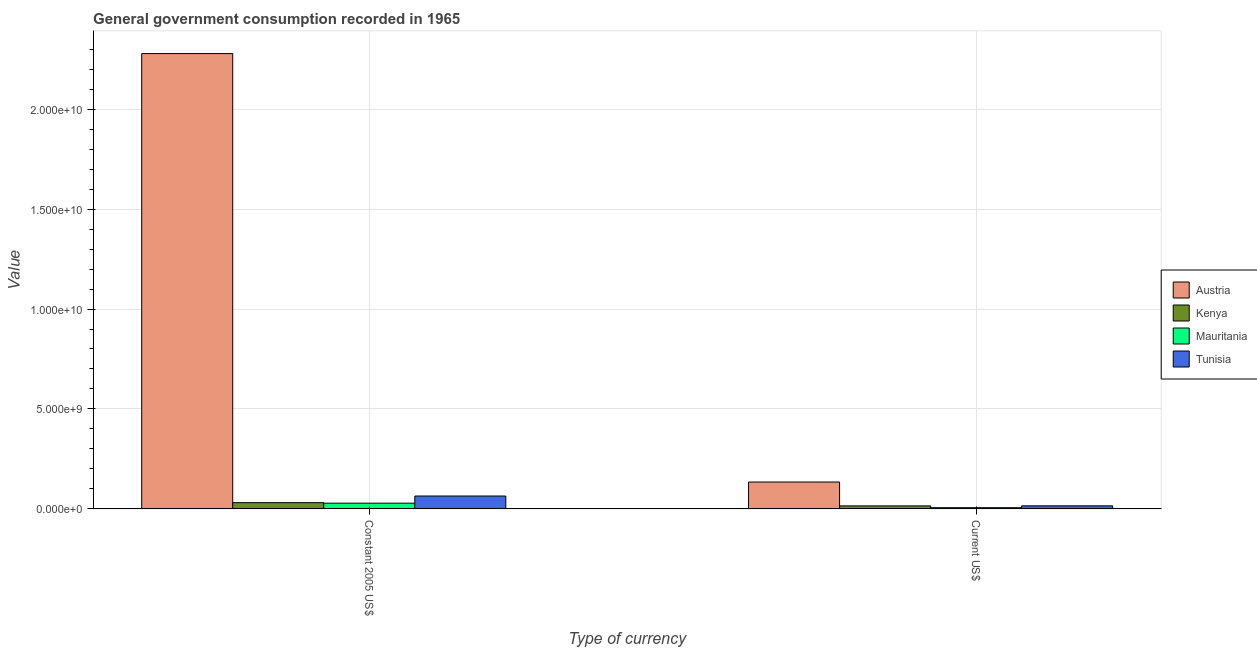How many different coloured bars are there?
Your answer should be compact. 4. Are the number of bars per tick equal to the number of legend labels?
Make the answer very short. Yes. How many bars are there on the 2nd tick from the left?
Your response must be concise. 4. How many bars are there on the 1st tick from the right?
Offer a terse response. 4. What is the label of the 2nd group of bars from the left?
Your answer should be compact. Current US$. What is the value consumed in constant 2005 us$ in Tunisia?
Offer a terse response. 6.42e+08. Across all countries, what is the maximum value consumed in current us$?
Ensure brevity in your answer.  1.34e+09. Across all countries, what is the minimum value consumed in current us$?
Provide a short and direct response. 5.77e+07. In which country was the value consumed in current us$ minimum?
Provide a succinct answer. Mauritania. What is the total value consumed in current us$ in the graph?
Ensure brevity in your answer.  1.70e+09. What is the difference between the value consumed in constant 2005 us$ in Mauritania and that in Tunisia?
Make the answer very short. -3.58e+08. What is the difference between the value consumed in current us$ in Mauritania and the value consumed in constant 2005 us$ in Austria?
Keep it short and to the point. -2.27e+1. What is the average value consumed in constant 2005 us$ per country?
Give a very brief answer. 6.00e+09. What is the difference between the value consumed in constant 2005 us$ and value consumed in current us$ in Tunisia?
Provide a short and direct response. 4.91e+08. In how many countries, is the value consumed in constant 2005 us$ greater than 6000000000 ?
Keep it short and to the point. 1. What is the ratio of the value consumed in constant 2005 us$ in Mauritania to that in Kenya?
Make the answer very short. 0.92. What does the 4th bar from the left in Constant 2005 US$ represents?
Keep it short and to the point. Tunisia. What does the 2nd bar from the right in Current US$ represents?
Your answer should be very brief. Mauritania. How many bars are there?
Your answer should be very brief. 8. Are all the bars in the graph horizontal?
Keep it short and to the point. No. How many countries are there in the graph?
Your answer should be very brief. 4. Does the graph contain grids?
Give a very brief answer. Yes. How are the legend labels stacked?
Give a very brief answer. Vertical. What is the title of the graph?
Keep it short and to the point. General government consumption recorded in 1965. What is the label or title of the X-axis?
Make the answer very short. Type of currency. What is the label or title of the Y-axis?
Offer a terse response. Value. What is the Value of Austria in Constant 2005 US$?
Your response must be concise. 2.28e+1. What is the Value in Kenya in Constant 2005 US$?
Provide a succinct answer. 3.09e+08. What is the Value of Mauritania in Constant 2005 US$?
Make the answer very short. 2.84e+08. What is the Value in Tunisia in Constant 2005 US$?
Provide a short and direct response. 6.42e+08. What is the Value of Austria in Current US$?
Your answer should be very brief. 1.34e+09. What is the Value in Kenya in Current US$?
Ensure brevity in your answer.  1.48e+08. What is the Value in Mauritania in Current US$?
Provide a succinct answer. 5.77e+07. What is the Value in Tunisia in Current US$?
Give a very brief answer. 1.50e+08. Across all Type of currency, what is the maximum Value in Austria?
Provide a succinct answer. 2.28e+1. Across all Type of currency, what is the maximum Value of Kenya?
Give a very brief answer. 3.09e+08. Across all Type of currency, what is the maximum Value of Mauritania?
Make the answer very short. 2.84e+08. Across all Type of currency, what is the maximum Value in Tunisia?
Offer a very short reply. 6.42e+08. Across all Type of currency, what is the minimum Value in Austria?
Provide a succinct answer. 1.34e+09. Across all Type of currency, what is the minimum Value of Kenya?
Ensure brevity in your answer.  1.48e+08. Across all Type of currency, what is the minimum Value of Mauritania?
Offer a terse response. 5.77e+07. Across all Type of currency, what is the minimum Value of Tunisia?
Offer a very short reply. 1.50e+08. What is the total Value in Austria in the graph?
Your response must be concise. 2.41e+1. What is the total Value of Kenya in the graph?
Your response must be concise. 4.57e+08. What is the total Value in Mauritania in the graph?
Your response must be concise. 3.42e+08. What is the total Value of Tunisia in the graph?
Your response must be concise. 7.92e+08. What is the difference between the Value in Austria in Constant 2005 US$ and that in Current US$?
Your response must be concise. 2.14e+1. What is the difference between the Value in Kenya in Constant 2005 US$ and that in Current US$?
Your answer should be compact. 1.61e+08. What is the difference between the Value in Mauritania in Constant 2005 US$ and that in Current US$?
Your answer should be compact. 2.26e+08. What is the difference between the Value of Tunisia in Constant 2005 US$ and that in Current US$?
Provide a succinct answer. 4.91e+08. What is the difference between the Value in Austria in Constant 2005 US$ and the Value in Kenya in Current US$?
Give a very brief answer. 2.26e+1. What is the difference between the Value of Austria in Constant 2005 US$ and the Value of Mauritania in Current US$?
Make the answer very short. 2.27e+1. What is the difference between the Value in Austria in Constant 2005 US$ and the Value in Tunisia in Current US$?
Offer a terse response. 2.26e+1. What is the difference between the Value of Kenya in Constant 2005 US$ and the Value of Mauritania in Current US$?
Offer a very short reply. 2.51e+08. What is the difference between the Value in Kenya in Constant 2005 US$ and the Value in Tunisia in Current US$?
Provide a short and direct response. 1.59e+08. What is the difference between the Value in Mauritania in Constant 2005 US$ and the Value in Tunisia in Current US$?
Ensure brevity in your answer.  1.34e+08. What is the average Value in Austria per Type of currency?
Ensure brevity in your answer.  1.21e+1. What is the average Value in Kenya per Type of currency?
Your response must be concise. 2.29e+08. What is the average Value in Mauritania per Type of currency?
Your answer should be compact. 1.71e+08. What is the average Value in Tunisia per Type of currency?
Your answer should be compact. 3.96e+08. What is the difference between the Value in Austria and Value in Kenya in Constant 2005 US$?
Provide a succinct answer. 2.25e+1. What is the difference between the Value in Austria and Value in Mauritania in Constant 2005 US$?
Provide a short and direct response. 2.25e+1. What is the difference between the Value in Austria and Value in Tunisia in Constant 2005 US$?
Your answer should be very brief. 2.21e+1. What is the difference between the Value in Kenya and Value in Mauritania in Constant 2005 US$?
Provide a short and direct response. 2.50e+07. What is the difference between the Value of Kenya and Value of Tunisia in Constant 2005 US$?
Give a very brief answer. -3.33e+08. What is the difference between the Value in Mauritania and Value in Tunisia in Constant 2005 US$?
Your answer should be compact. -3.58e+08. What is the difference between the Value in Austria and Value in Kenya in Current US$?
Provide a succinct answer. 1.19e+09. What is the difference between the Value in Austria and Value in Mauritania in Current US$?
Provide a succinct answer. 1.28e+09. What is the difference between the Value of Austria and Value of Tunisia in Current US$?
Give a very brief answer. 1.19e+09. What is the difference between the Value in Kenya and Value in Mauritania in Current US$?
Offer a terse response. 9.04e+07. What is the difference between the Value in Kenya and Value in Tunisia in Current US$?
Provide a succinct answer. -2.36e+06. What is the difference between the Value of Mauritania and Value of Tunisia in Current US$?
Make the answer very short. -9.28e+07. What is the ratio of the Value in Austria in Constant 2005 US$ to that in Current US$?
Make the answer very short. 16.98. What is the ratio of the Value in Kenya in Constant 2005 US$ to that in Current US$?
Offer a terse response. 2.09. What is the ratio of the Value of Mauritania in Constant 2005 US$ to that in Current US$?
Offer a terse response. 4.92. What is the ratio of the Value of Tunisia in Constant 2005 US$ to that in Current US$?
Your answer should be very brief. 4.27. What is the difference between the highest and the second highest Value of Austria?
Make the answer very short. 2.14e+1. What is the difference between the highest and the second highest Value of Kenya?
Your answer should be very brief. 1.61e+08. What is the difference between the highest and the second highest Value in Mauritania?
Offer a very short reply. 2.26e+08. What is the difference between the highest and the second highest Value in Tunisia?
Provide a short and direct response. 4.91e+08. What is the difference between the highest and the lowest Value in Austria?
Your answer should be compact. 2.14e+1. What is the difference between the highest and the lowest Value in Kenya?
Keep it short and to the point. 1.61e+08. What is the difference between the highest and the lowest Value of Mauritania?
Ensure brevity in your answer.  2.26e+08. What is the difference between the highest and the lowest Value of Tunisia?
Your response must be concise. 4.91e+08. 